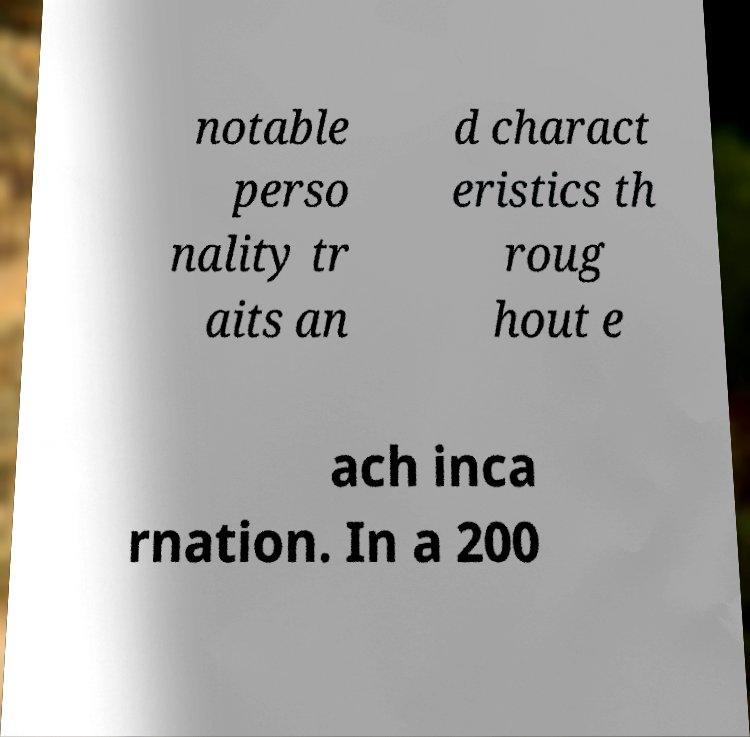There's text embedded in this image that I need extracted. Can you transcribe it verbatim? notable perso nality tr aits an d charact eristics th roug hout e ach inca rnation. In a 200 